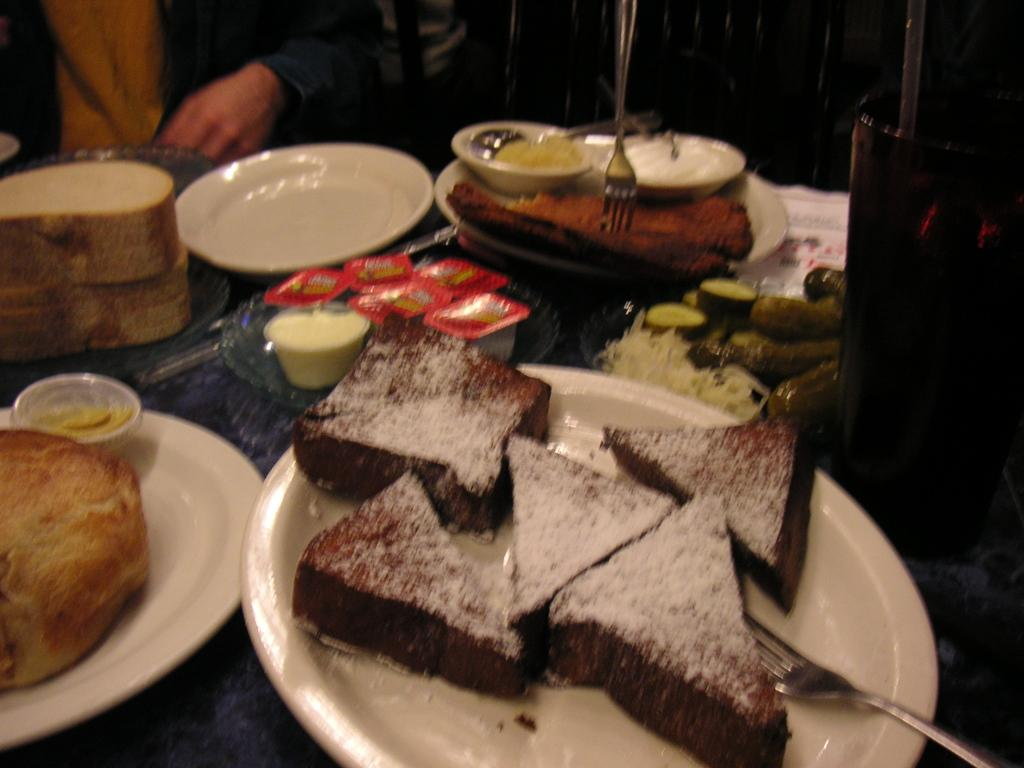What types of food items can be seen on the table in the image? There are desserts, creams, cucumber, and breads among the food items on the table. What tableware is present on the table? There are plates and forks on the table. Is there anyone in the image interacting with the food items? Yes, there is a person sitting in front of the table. What type of leather can be seen on the table in the image? There is no leather present on the table in the image. Can you describe the cloud formation visible through the window in the image? There is no window or cloud formation visible in the image. 